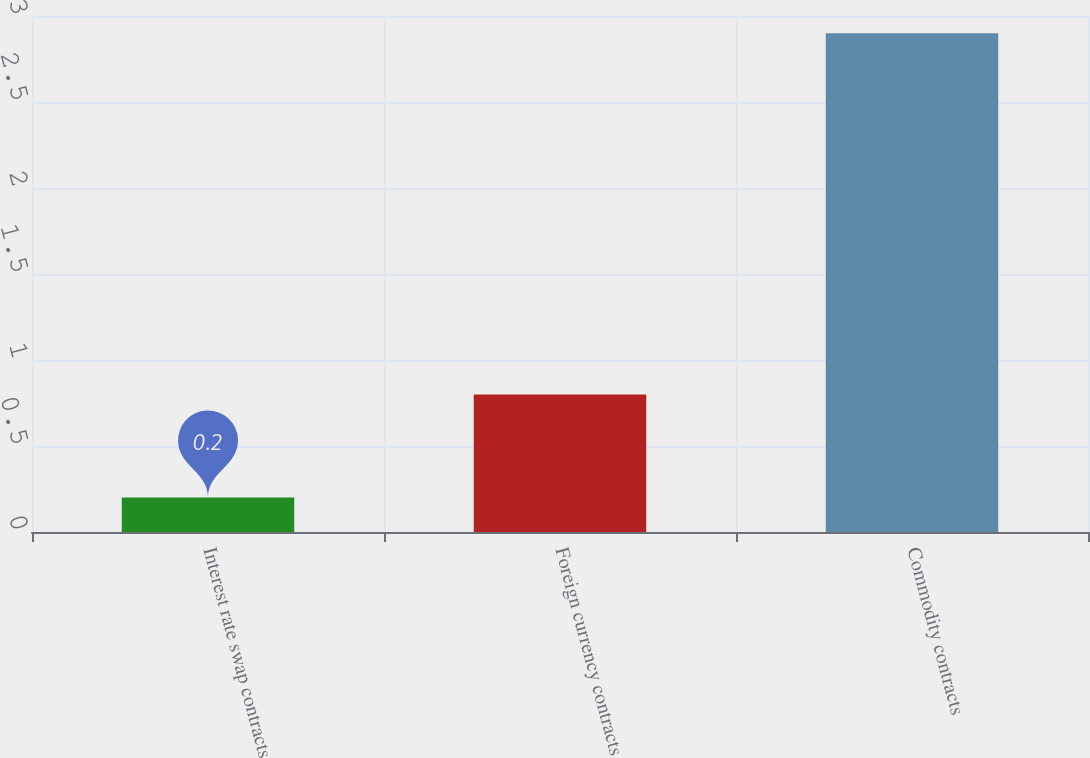Convert chart. <chart><loc_0><loc_0><loc_500><loc_500><bar_chart><fcel>Interest rate swap contracts<fcel>Foreign currency contracts<fcel>Commodity contracts<nl><fcel>0.2<fcel>0.8<fcel>2.9<nl></chart> 